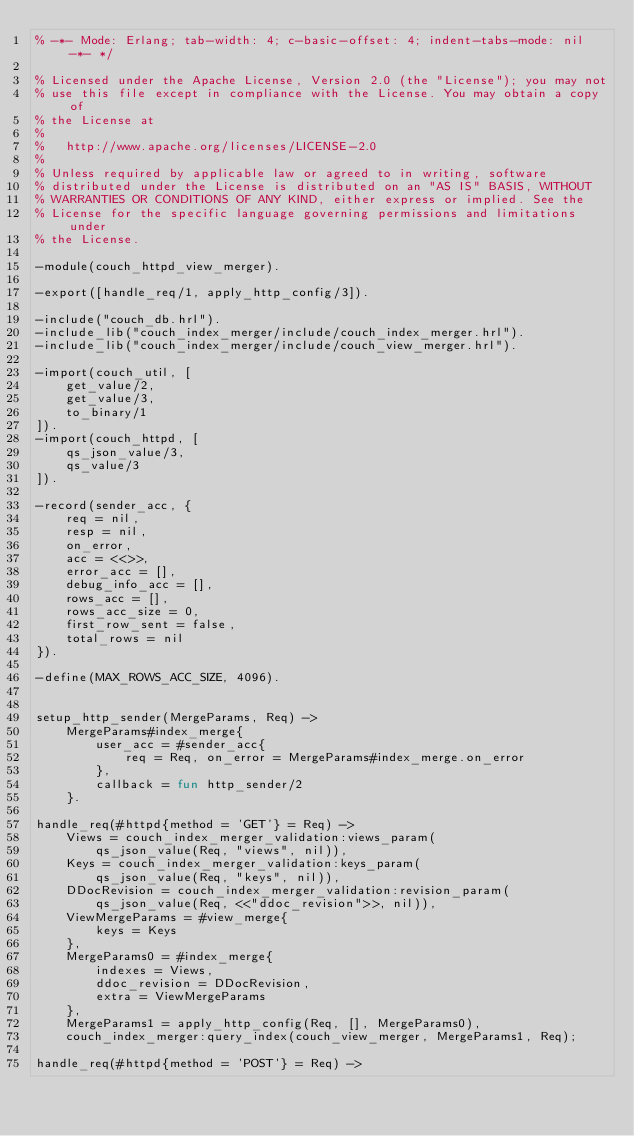<code> <loc_0><loc_0><loc_500><loc_500><_Erlang_>% -*- Mode: Erlang; tab-width: 4; c-basic-offset: 4; indent-tabs-mode: nil -*- */

% Licensed under the Apache License, Version 2.0 (the "License"); you may not
% use this file except in compliance with the License. You may obtain a copy of
% the License at
%
%   http://www.apache.org/licenses/LICENSE-2.0
%
% Unless required by applicable law or agreed to in writing, software
% distributed under the License is distributed on an "AS IS" BASIS, WITHOUT
% WARRANTIES OR CONDITIONS OF ANY KIND, either express or implied. See the
% License for the specific language governing permissions and limitations under
% the License.

-module(couch_httpd_view_merger).

-export([handle_req/1, apply_http_config/3]).

-include("couch_db.hrl").
-include_lib("couch_index_merger/include/couch_index_merger.hrl").
-include_lib("couch_index_merger/include/couch_view_merger.hrl").

-import(couch_util, [
    get_value/2,
    get_value/3,
    to_binary/1
]).
-import(couch_httpd, [
    qs_json_value/3,
    qs_value/3
]).

-record(sender_acc, {
    req = nil,
    resp = nil,
    on_error,
    acc = <<>>,
    error_acc = [],
    debug_info_acc = [],
    rows_acc = [],
    rows_acc_size = 0,
    first_row_sent = false,
    total_rows = nil
}).

-define(MAX_ROWS_ACC_SIZE, 4096).


setup_http_sender(MergeParams, Req) ->
    MergeParams#index_merge{
        user_acc = #sender_acc{
            req = Req, on_error = MergeParams#index_merge.on_error
        },
        callback = fun http_sender/2
    }.

handle_req(#httpd{method = 'GET'} = Req) ->
    Views = couch_index_merger_validation:views_param(
        qs_json_value(Req, "views", nil)),
    Keys = couch_index_merger_validation:keys_param(
        qs_json_value(Req, "keys", nil)),
    DDocRevision = couch_index_merger_validation:revision_param(
        qs_json_value(Req, <<"ddoc_revision">>, nil)),
    ViewMergeParams = #view_merge{
        keys = Keys
    },
    MergeParams0 = #index_merge{
        indexes = Views,
        ddoc_revision = DDocRevision,
        extra = ViewMergeParams
    },
    MergeParams1 = apply_http_config(Req, [], MergeParams0),
    couch_index_merger:query_index(couch_view_merger, MergeParams1, Req);

handle_req(#httpd{method = 'POST'} = Req) -></code> 